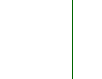<code> <loc_0><loc_0><loc_500><loc_500><_Bash_>
</code> 